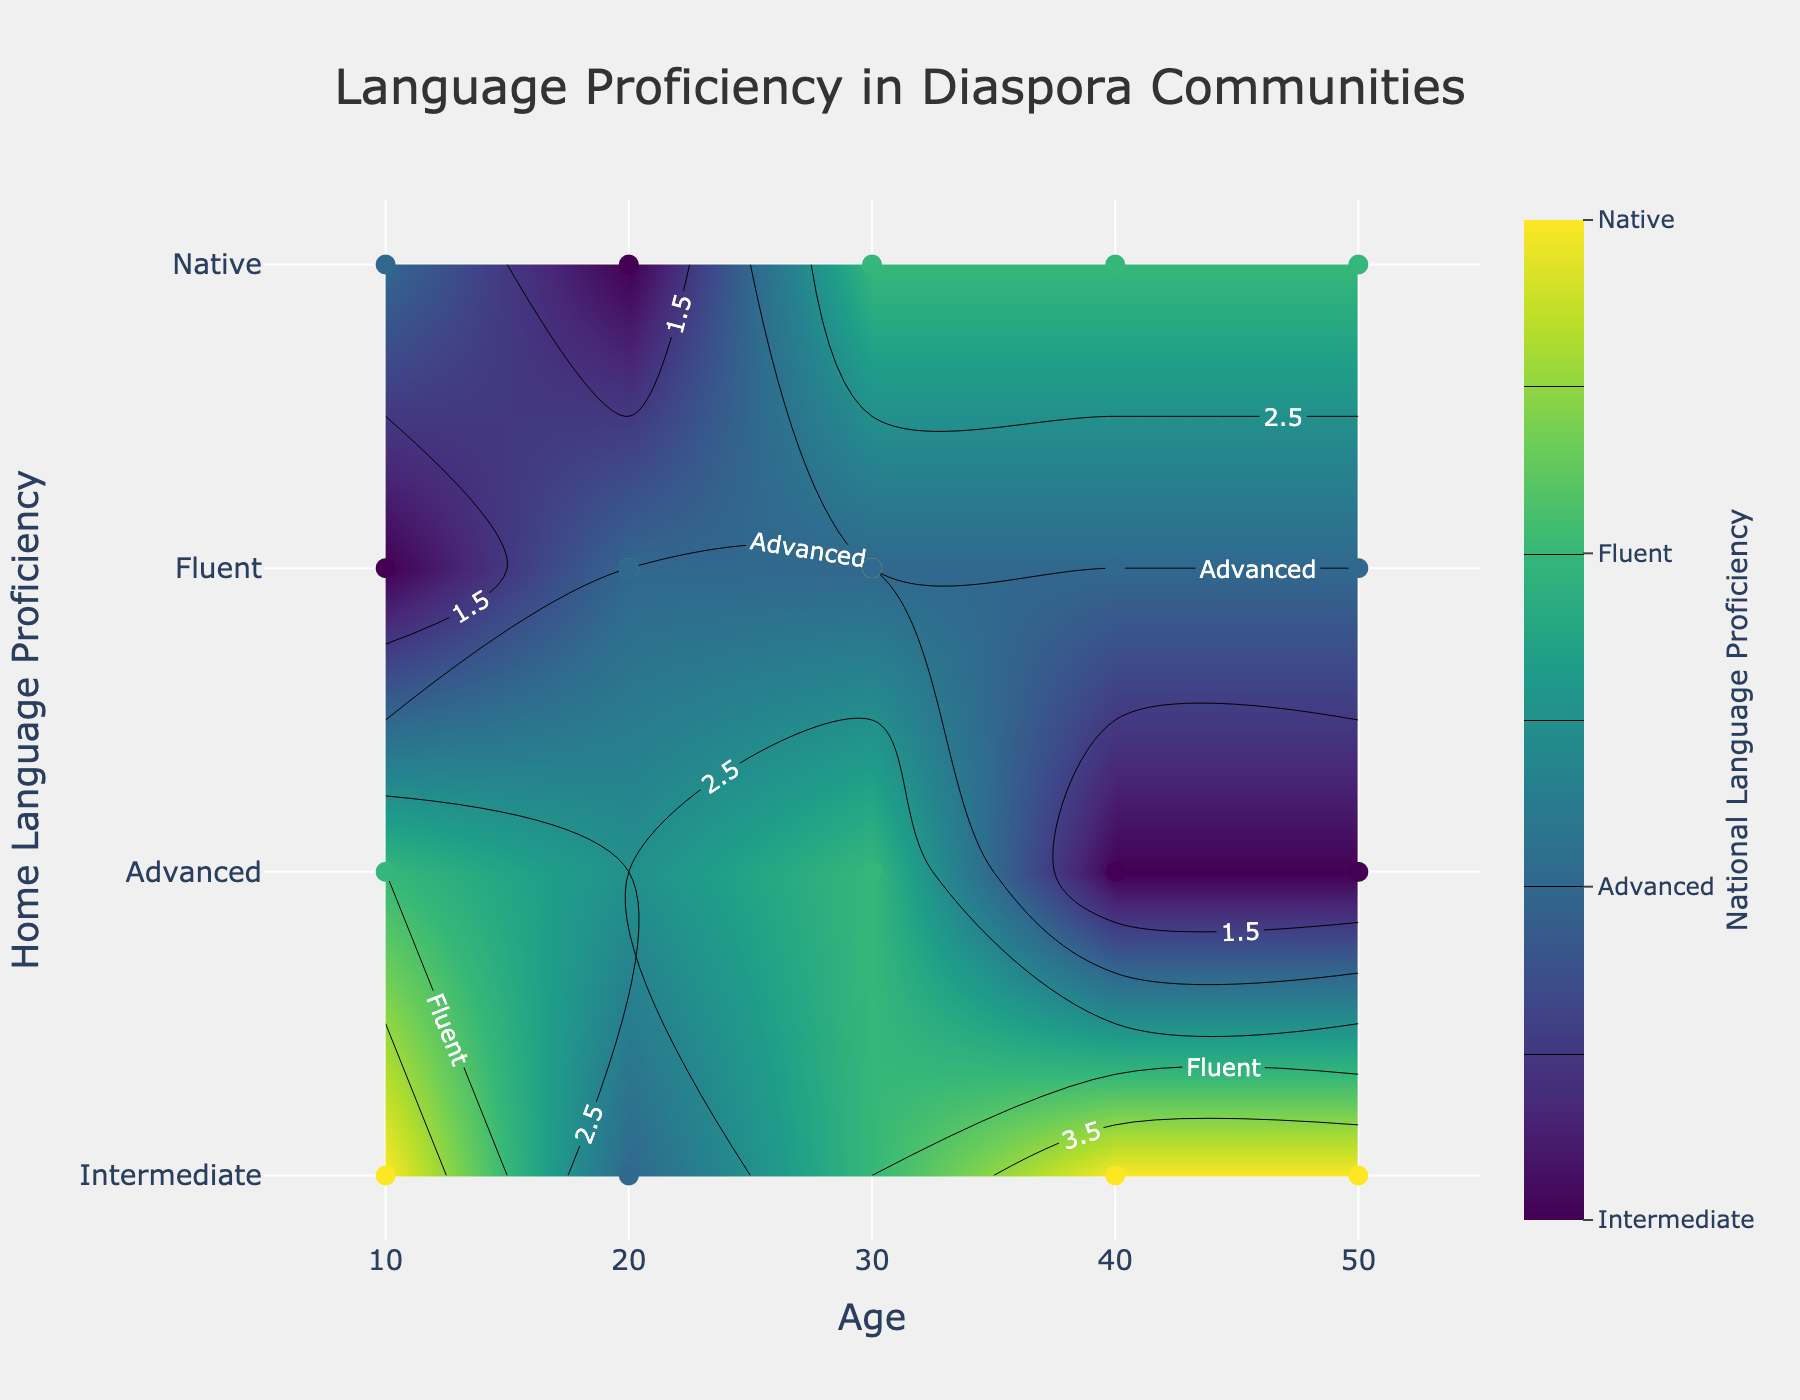What is the title of the figure? The title is usually displayed at the top of the figure in a larger or bold font. By directly looking at the figure, you can read the title text.
Answer: Language Proficiency in Diaspora Communities What are the x-axis and y-axis labels? The labels for the x-axis and y-axis are indicated near the respective axes of the figure. They provide information about what each axis represents.
Answer: x-axis: Age, y-axis: Home Language Proficiency What is the range of the y-axis? The y-axis range includes all the tick values labeled from the bottom to the top of the y-axis. By reading these tick labels, you can determine the range.
Answer: 1 to 4 How many proficiency levels are represented in the color bar? The color bar usually contains tick marks with labels that indicate different proficiency levels. Count the number of unique labels on the color bar.
Answer: 4 What place of birth has a 10-year-old with intermediate national language proficiency? Identify the data points plotted on the figure. Find the one at age 10 with a color corresponding to intermediate proficiency, and check its hover text for the place of birth.
Answer: Toronto What is the average national language proficiency for 30-year-olds? To find this average, look at all data points for 30-year-olds, note their national language proficiency levels, convert these to numeric values, and calculate the mean. Two 30-year-olds have 'Fluent' and 'Advanced' proficiency, mapping to 3 and 2 respectively.
Answer: (4+3+2+3)/4 = 3 Which age group shows the highest home language proficiency and national language proficiency? Examine all age groups and find the one which has the highest home language proficiency combined with national language proficiency.
Answer: Age 10 in Toronto and Berlin Which age group shows the lowest home and national language proficiency values? Investigate all age groups and find the one which has the lowest combined home and national language proficiency.
Answer: Age 40 in Melbourne Which age and place of birth show a native level of both home and national language proficiency? Search for data points where both proficiencies are at native level by correlating ages and respective place of birth from the hover information.
Answer: Age 50 in Berlin 